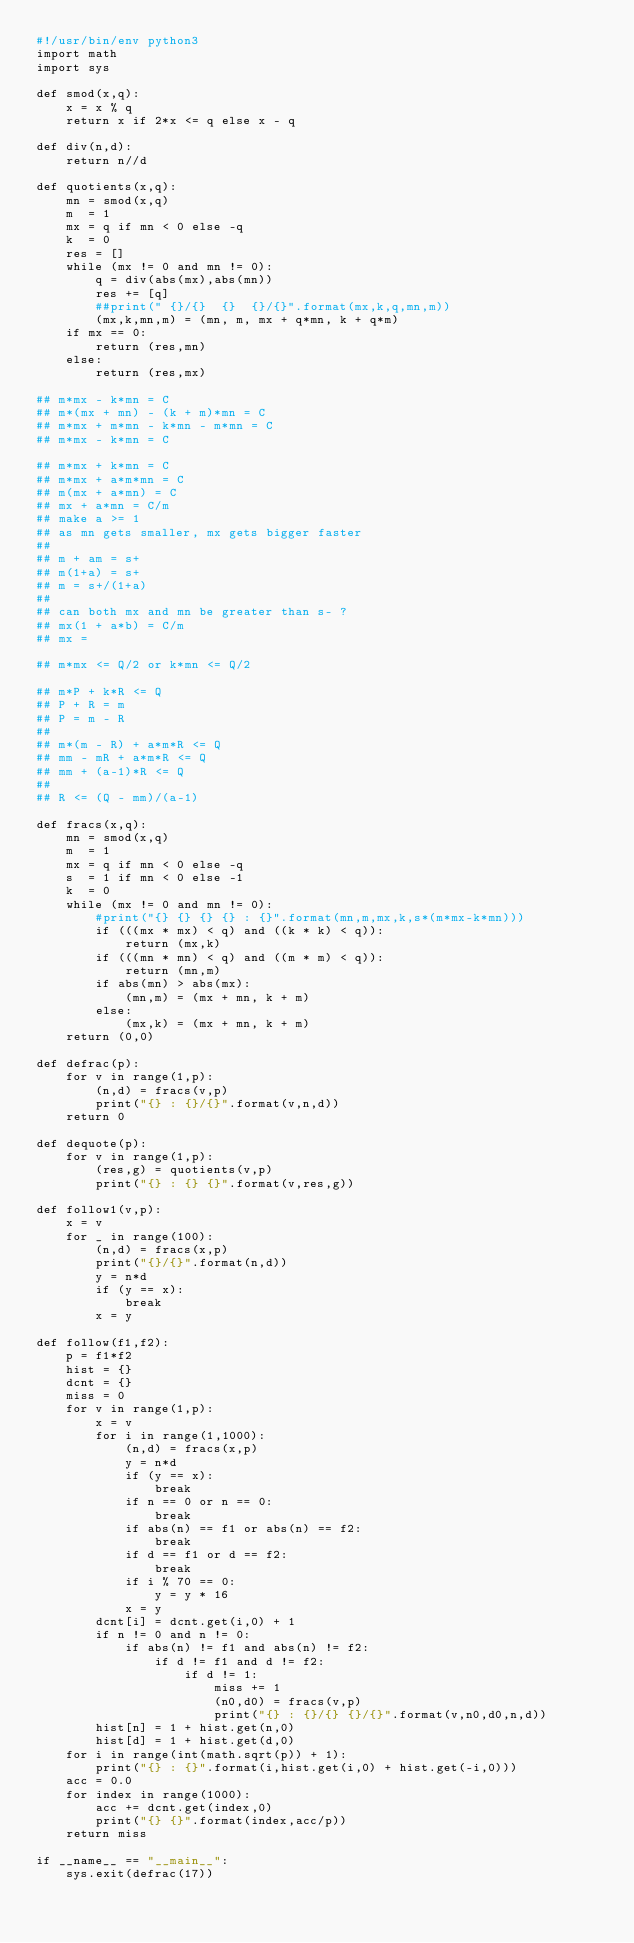<code> <loc_0><loc_0><loc_500><loc_500><_Python_>#!/usr/bin/env python3
import math
import sys

def smod(x,q):
    x = x % q
    return x if 2*x <= q else x - q

def div(n,d):
    return n//d

def quotients(x,q):
    mn = smod(x,q)
    m  = 1
    mx = q if mn < 0 else -q
    k  = 0
    res = []
    while (mx != 0 and mn != 0):
        q = div(abs(mx),abs(mn))
        res += [q]
        ##print(" {}/{}  {}  {}/{}".format(mx,k,q,mn,m))
        (mx,k,mn,m) = (mn, m, mx + q*mn, k + q*m)
    if mx == 0:
        return (res,mn)
    else:
        return (res,mx)

## m*mx - k*mn = C
## m*(mx + mn) - (k + m)*mn = C
## m*mx + m*mn - k*mn - m*mn = C
## m*mx - k*mn = C

## m*mx + k*mn = C
## m*mx + a*m*mn = C
## m(mx + a*mn) = C
## mx + a*mn = C/m
## make a >= 1
## as mn gets smaller, mx gets bigger faster
## 
## m + am = s+
## m(1+a) = s+
## m = s+/(1+a)
## 
## can both mx and mn be greater than s- ?
## mx(1 + a*b) = C/m
## mx = 

## m*mx <= Q/2 or k*mn <= Q/2

## m*P + k*R <= Q
## P + R = m
## P = m - R
##
## m*(m - R) + a*m*R <= Q
## mm - mR + a*m*R <= Q
## mm + (a-1)*R <= Q
##
## R <= (Q - mm)/(a-1)

def fracs(x,q):
    mn = smod(x,q)
    m  = 1
    mx = q if mn < 0 else -q
    s  = 1 if mn < 0 else -1
    k  = 0
    while (mx != 0 and mn != 0):
        #print("{} {} {} {} : {}".format(mn,m,mx,k,s*(m*mx-k*mn)))
        if (((mx * mx) < q) and ((k * k) < q)):
            return (mx,k)
        if (((mn * mn) < q) and ((m * m) < q)):
            return (mn,m)
        if abs(mn) > abs(mx):
            (mn,m) = (mx + mn, k + m)
        else:
            (mx,k) = (mx + mn, k + m)
    return (0,0)

def defrac(p):
    for v in range(1,p):
        (n,d) = fracs(v,p)
        print("{} : {}/{}".format(v,n,d))
    return 0

def dequote(p):
    for v in range(1,p):
        (res,g) = quotients(v,p)
        print("{} : {} {}".format(v,res,g))

def follow1(v,p):
    x = v
    for _ in range(100):
        (n,d) = fracs(x,p)
        print("{}/{}".format(n,d))
        y = n*d
        if (y == x):
            break
        x = y

def follow(f1,f2):
    p = f1*f2
    hist = {}
    dcnt = {}
    miss = 0
    for v in range(1,p):
        x = v
        for i in range(1,1000):
            (n,d) = fracs(x,p)
            y = n*d
            if (y == x):
                break
            if n == 0 or n == 0:
                break
            if abs(n) == f1 or abs(n) == f2:
                break
            if d == f1 or d == f2:
                break
            if i % 70 == 0:
                y = y * 16
            x = y
        dcnt[i] = dcnt.get(i,0) + 1
        if n != 0 and n != 0:
            if abs(n) != f1 and abs(n) != f2:
                if d != f1 and d != f2:
                    if d != 1:
                        miss += 1
                        (n0,d0) = fracs(v,p)
                        print("{} : {}/{} {}/{}".format(v,n0,d0,n,d))
        hist[n] = 1 + hist.get(n,0)
        hist[d] = 1 + hist.get(d,0)
    for i in range(int(math.sqrt(p)) + 1):
        print("{} : {}".format(i,hist.get(i,0) + hist.get(-i,0)))
    acc = 0.0
    for index in range(1000):
        acc += dcnt.get(index,0)
        print("{} {}".format(index,acc/p))
    return miss

if __name__ == "__main__":
    sys.exit(defrac(17))
</code> 